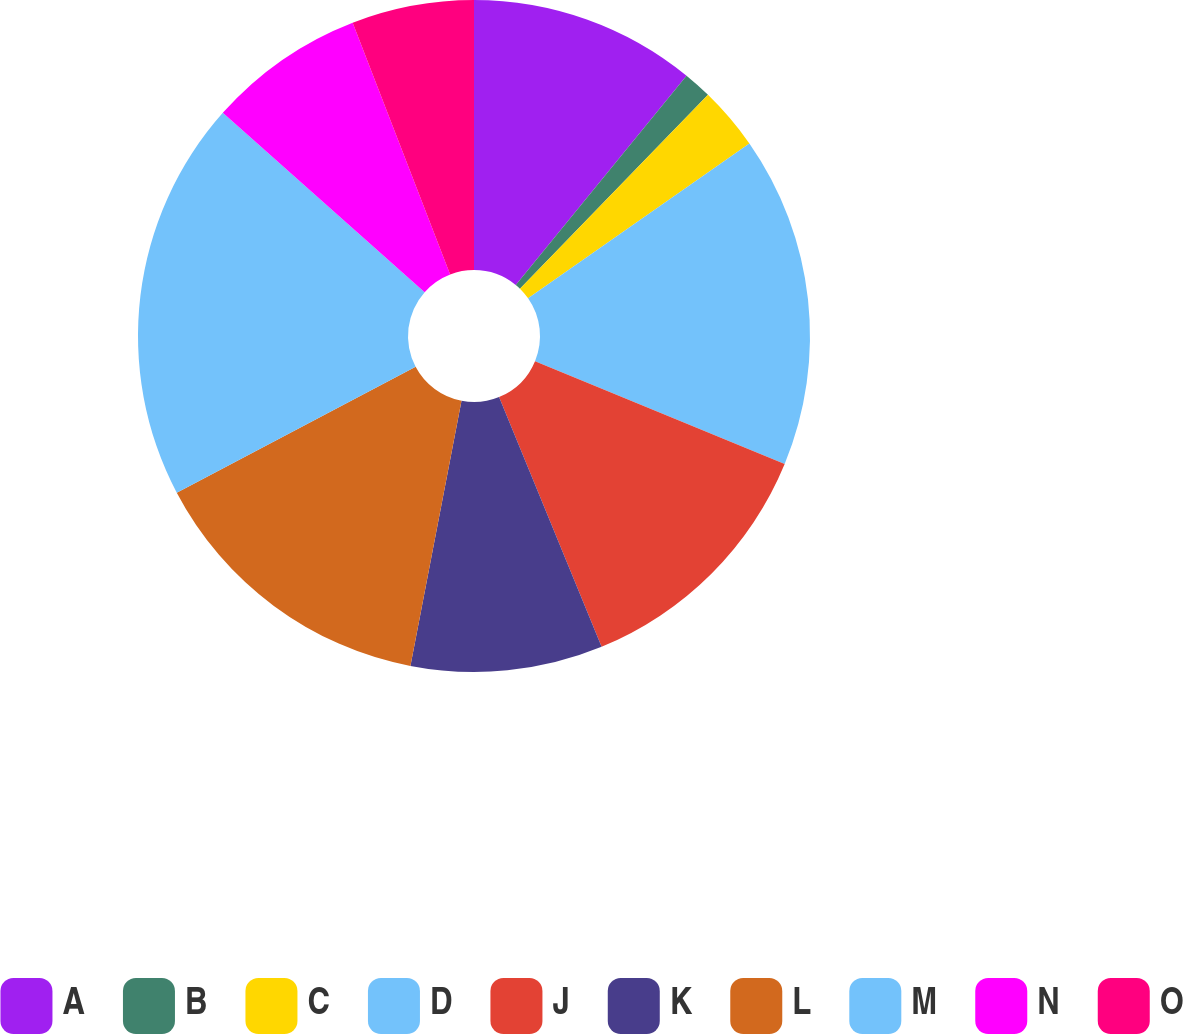<chart> <loc_0><loc_0><loc_500><loc_500><pie_chart><fcel>A<fcel>B<fcel>C<fcel>D<fcel>J<fcel>K<fcel>L<fcel>M<fcel>N<fcel>O<nl><fcel>10.9%<fcel>1.36%<fcel>3.03%<fcel>15.93%<fcel>12.58%<fcel>9.23%<fcel>14.25%<fcel>19.28%<fcel>7.56%<fcel>5.88%<nl></chart> 